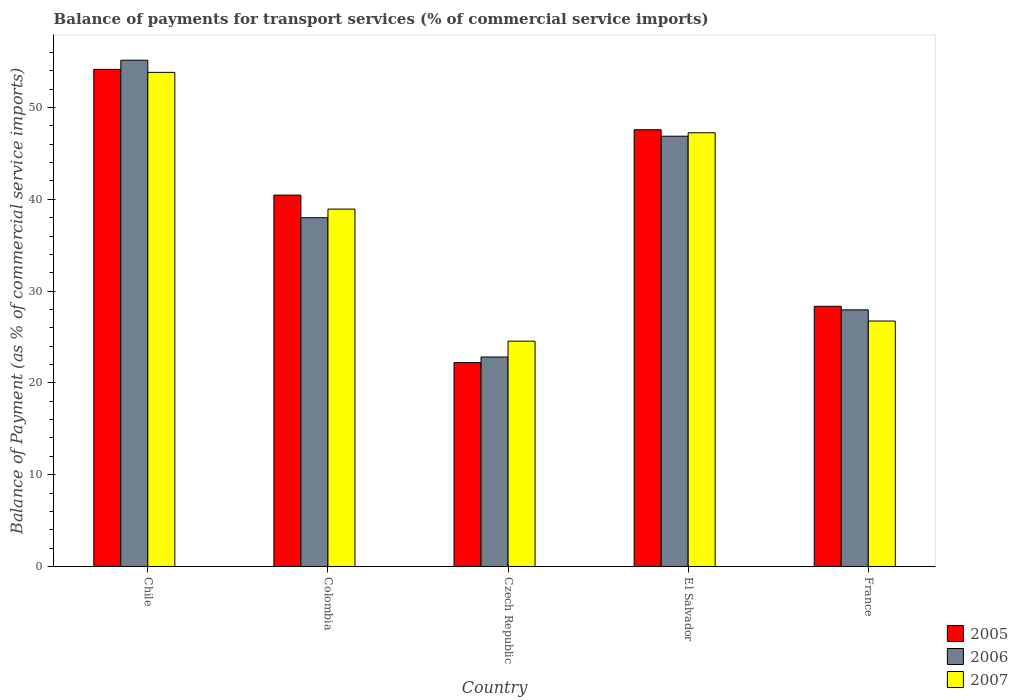How many different coloured bars are there?
Your response must be concise. 3. Are the number of bars per tick equal to the number of legend labels?
Your response must be concise. Yes. How many bars are there on the 3rd tick from the left?
Keep it short and to the point. 3. What is the label of the 1st group of bars from the left?
Ensure brevity in your answer.  Chile. What is the balance of payments for transport services in 2007 in Czech Republic?
Your response must be concise. 24.55. Across all countries, what is the maximum balance of payments for transport services in 2007?
Give a very brief answer. 53.83. Across all countries, what is the minimum balance of payments for transport services in 2007?
Give a very brief answer. 24.55. In which country was the balance of payments for transport services in 2006 minimum?
Ensure brevity in your answer.  Czech Republic. What is the total balance of payments for transport services in 2006 in the graph?
Your answer should be very brief. 190.83. What is the difference between the balance of payments for transport services in 2005 in Czech Republic and that in El Salvador?
Provide a short and direct response. -25.37. What is the difference between the balance of payments for transport services in 2007 in Colombia and the balance of payments for transport services in 2005 in Chile?
Give a very brief answer. -15.22. What is the average balance of payments for transport services in 2007 per country?
Provide a short and direct response. 38.26. What is the difference between the balance of payments for transport services of/in 2006 and balance of payments for transport services of/in 2005 in Colombia?
Your response must be concise. -2.46. In how many countries, is the balance of payments for transport services in 2005 greater than 4 %?
Give a very brief answer. 5. What is the ratio of the balance of payments for transport services in 2007 in Chile to that in France?
Your response must be concise. 2.01. Is the difference between the balance of payments for transport services in 2006 in Czech Republic and France greater than the difference between the balance of payments for transport services in 2005 in Czech Republic and France?
Offer a terse response. Yes. What is the difference between the highest and the second highest balance of payments for transport services in 2006?
Provide a short and direct response. -8.88. What is the difference between the highest and the lowest balance of payments for transport services in 2005?
Ensure brevity in your answer.  31.95. Is the sum of the balance of payments for transport services in 2007 in Colombia and Czech Republic greater than the maximum balance of payments for transport services in 2006 across all countries?
Provide a short and direct response. Yes. What does the 2nd bar from the left in Czech Republic represents?
Make the answer very short. 2006. Is it the case that in every country, the sum of the balance of payments for transport services in 2005 and balance of payments for transport services in 2006 is greater than the balance of payments for transport services in 2007?
Make the answer very short. Yes. Does the graph contain any zero values?
Your answer should be compact. No. Does the graph contain grids?
Keep it short and to the point. No. Where does the legend appear in the graph?
Offer a very short reply. Bottom right. How many legend labels are there?
Your answer should be very brief. 3. How are the legend labels stacked?
Your response must be concise. Vertical. What is the title of the graph?
Your answer should be very brief. Balance of payments for transport services (% of commercial service imports). What is the label or title of the X-axis?
Your response must be concise. Country. What is the label or title of the Y-axis?
Your answer should be very brief. Balance of Payment (as % of commercial service imports). What is the Balance of Payment (as % of commercial service imports) in 2005 in Chile?
Offer a very short reply. 54.16. What is the Balance of Payment (as % of commercial service imports) of 2006 in Chile?
Keep it short and to the point. 55.16. What is the Balance of Payment (as % of commercial service imports) of 2007 in Chile?
Make the answer very short. 53.83. What is the Balance of Payment (as % of commercial service imports) in 2005 in Colombia?
Your answer should be very brief. 40.46. What is the Balance of Payment (as % of commercial service imports) in 2006 in Colombia?
Provide a succinct answer. 38. What is the Balance of Payment (as % of commercial service imports) of 2007 in Colombia?
Provide a succinct answer. 38.94. What is the Balance of Payment (as % of commercial service imports) in 2005 in Czech Republic?
Give a very brief answer. 22.21. What is the Balance of Payment (as % of commercial service imports) in 2006 in Czech Republic?
Keep it short and to the point. 22.82. What is the Balance of Payment (as % of commercial service imports) in 2007 in Czech Republic?
Make the answer very short. 24.55. What is the Balance of Payment (as % of commercial service imports) in 2005 in El Salvador?
Your response must be concise. 47.58. What is the Balance of Payment (as % of commercial service imports) in 2006 in El Salvador?
Provide a succinct answer. 46.88. What is the Balance of Payment (as % of commercial service imports) in 2007 in El Salvador?
Provide a short and direct response. 47.25. What is the Balance of Payment (as % of commercial service imports) in 2005 in France?
Keep it short and to the point. 28.35. What is the Balance of Payment (as % of commercial service imports) of 2006 in France?
Your response must be concise. 27.96. What is the Balance of Payment (as % of commercial service imports) in 2007 in France?
Your answer should be compact. 26.74. Across all countries, what is the maximum Balance of Payment (as % of commercial service imports) in 2005?
Keep it short and to the point. 54.16. Across all countries, what is the maximum Balance of Payment (as % of commercial service imports) in 2006?
Offer a very short reply. 55.16. Across all countries, what is the maximum Balance of Payment (as % of commercial service imports) in 2007?
Provide a succinct answer. 53.83. Across all countries, what is the minimum Balance of Payment (as % of commercial service imports) in 2005?
Give a very brief answer. 22.21. Across all countries, what is the minimum Balance of Payment (as % of commercial service imports) in 2006?
Your answer should be very brief. 22.82. Across all countries, what is the minimum Balance of Payment (as % of commercial service imports) in 2007?
Provide a short and direct response. 24.55. What is the total Balance of Payment (as % of commercial service imports) in 2005 in the graph?
Keep it short and to the point. 192.76. What is the total Balance of Payment (as % of commercial service imports) in 2006 in the graph?
Your response must be concise. 190.83. What is the total Balance of Payment (as % of commercial service imports) of 2007 in the graph?
Your answer should be very brief. 191.32. What is the difference between the Balance of Payment (as % of commercial service imports) in 2005 in Chile and that in Colombia?
Offer a terse response. 13.7. What is the difference between the Balance of Payment (as % of commercial service imports) in 2006 in Chile and that in Colombia?
Keep it short and to the point. 17.16. What is the difference between the Balance of Payment (as % of commercial service imports) in 2007 in Chile and that in Colombia?
Your answer should be very brief. 14.9. What is the difference between the Balance of Payment (as % of commercial service imports) of 2005 in Chile and that in Czech Republic?
Your answer should be compact. 31.95. What is the difference between the Balance of Payment (as % of commercial service imports) in 2006 in Chile and that in Czech Republic?
Offer a terse response. 32.34. What is the difference between the Balance of Payment (as % of commercial service imports) of 2007 in Chile and that in Czech Republic?
Your response must be concise. 29.28. What is the difference between the Balance of Payment (as % of commercial service imports) in 2005 in Chile and that in El Salvador?
Make the answer very short. 6.58. What is the difference between the Balance of Payment (as % of commercial service imports) in 2006 in Chile and that in El Salvador?
Offer a very short reply. 8.28. What is the difference between the Balance of Payment (as % of commercial service imports) of 2007 in Chile and that in El Salvador?
Offer a very short reply. 6.58. What is the difference between the Balance of Payment (as % of commercial service imports) in 2005 in Chile and that in France?
Ensure brevity in your answer.  25.81. What is the difference between the Balance of Payment (as % of commercial service imports) of 2006 in Chile and that in France?
Your response must be concise. 27.2. What is the difference between the Balance of Payment (as % of commercial service imports) in 2007 in Chile and that in France?
Offer a terse response. 27.09. What is the difference between the Balance of Payment (as % of commercial service imports) of 2005 in Colombia and that in Czech Republic?
Your answer should be very brief. 18.25. What is the difference between the Balance of Payment (as % of commercial service imports) in 2006 in Colombia and that in Czech Republic?
Offer a terse response. 15.18. What is the difference between the Balance of Payment (as % of commercial service imports) in 2007 in Colombia and that in Czech Republic?
Offer a terse response. 14.39. What is the difference between the Balance of Payment (as % of commercial service imports) in 2005 in Colombia and that in El Salvador?
Offer a very short reply. -7.12. What is the difference between the Balance of Payment (as % of commercial service imports) in 2006 in Colombia and that in El Salvador?
Provide a short and direct response. -8.88. What is the difference between the Balance of Payment (as % of commercial service imports) in 2007 in Colombia and that in El Salvador?
Offer a very short reply. -8.32. What is the difference between the Balance of Payment (as % of commercial service imports) in 2005 in Colombia and that in France?
Your response must be concise. 12.11. What is the difference between the Balance of Payment (as % of commercial service imports) of 2006 in Colombia and that in France?
Offer a terse response. 10.04. What is the difference between the Balance of Payment (as % of commercial service imports) of 2007 in Colombia and that in France?
Ensure brevity in your answer.  12.2. What is the difference between the Balance of Payment (as % of commercial service imports) of 2005 in Czech Republic and that in El Salvador?
Offer a very short reply. -25.37. What is the difference between the Balance of Payment (as % of commercial service imports) in 2006 in Czech Republic and that in El Salvador?
Provide a short and direct response. -24.05. What is the difference between the Balance of Payment (as % of commercial service imports) of 2007 in Czech Republic and that in El Salvador?
Offer a very short reply. -22.7. What is the difference between the Balance of Payment (as % of commercial service imports) in 2005 in Czech Republic and that in France?
Give a very brief answer. -6.14. What is the difference between the Balance of Payment (as % of commercial service imports) of 2006 in Czech Republic and that in France?
Offer a terse response. -5.14. What is the difference between the Balance of Payment (as % of commercial service imports) of 2007 in Czech Republic and that in France?
Your answer should be very brief. -2.19. What is the difference between the Balance of Payment (as % of commercial service imports) in 2005 in El Salvador and that in France?
Keep it short and to the point. 19.23. What is the difference between the Balance of Payment (as % of commercial service imports) of 2006 in El Salvador and that in France?
Offer a very short reply. 18.92. What is the difference between the Balance of Payment (as % of commercial service imports) of 2007 in El Salvador and that in France?
Make the answer very short. 20.51. What is the difference between the Balance of Payment (as % of commercial service imports) of 2005 in Chile and the Balance of Payment (as % of commercial service imports) of 2006 in Colombia?
Ensure brevity in your answer.  16.16. What is the difference between the Balance of Payment (as % of commercial service imports) of 2005 in Chile and the Balance of Payment (as % of commercial service imports) of 2007 in Colombia?
Give a very brief answer. 15.22. What is the difference between the Balance of Payment (as % of commercial service imports) of 2006 in Chile and the Balance of Payment (as % of commercial service imports) of 2007 in Colombia?
Keep it short and to the point. 16.22. What is the difference between the Balance of Payment (as % of commercial service imports) of 2005 in Chile and the Balance of Payment (as % of commercial service imports) of 2006 in Czech Republic?
Your answer should be very brief. 31.34. What is the difference between the Balance of Payment (as % of commercial service imports) of 2005 in Chile and the Balance of Payment (as % of commercial service imports) of 2007 in Czech Republic?
Your answer should be compact. 29.61. What is the difference between the Balance of Payment (as % of commercial service imports) in 2006 in Chile and the Balance of Payment (as % of commercial service imports) in 2007 in Czech Republic?
Ensure brevity in your answer.  30.61. What is the difference between the Balance of Payment (as % of commercial service imports) in 2005 in Chile and the Balance of Payment (as % of commercial service imports) in 2006 in El Salvador?
Offer a very short reply. 7.28. What is the difference between the Balance of Payment (as % of commercial service imports) of 2005 in Chile and the Balance of Payment (as % of commercial service imports) of 2007 in El Salvador?
Keep it short and to the point. 6.91. What is the difference between the Balance of Payment (as % of commercial service imports) of 2006 in Chile and the Balance of Payment (as % of commercial service imports) of 2007 in El Salvador?
Make the answer very short. 7.91. What is the difference between the Balance of Payment (as % of commercial service imports) of 2005 in Chile and the Balance of Payment (as % of commercial service imports) of 2006 in France?
Give a very brief answer. 26.2. What is the difference between the Balance of Payment (as % of commercial service imports) of 2005 in Chile and the Balance of Payment (as % of commercial service imports) of 2007 in France?
Your answer should be very brief. 27.42. What is the difference between the Balance of Payment (as % of commercial service imports) in 2006 in Chile and the Balance of Payment (as % of commercial service imports) in 2007 in France?
Your answer should be very brief. 28.42. What is the difference between the Balance of Payment (as % of commercial service imports) of 2005 in Colombia and the Balance of Payment (as % of commercial service imports) of 2006 in Czech Republic?
Your answer should be very brief. 17.64. What is the difference between the Balance of Payment (as % of commercial service imports) in 2005 in Colombia and the Balance of Payment (as % of commercial service imports) in 2007 in Czech Republic?
Ensure brevity in your answer.  15.91. What is the difference between the Balance of Payment (as % of commercial service imports) in 2006 in Colombia and the Balance of Payment (as % of commercial service imports) in 2007 in Czech Republic?
Keep it short and to the point. 13.45. What is the difference between the Balance of Payment (as % of commercial service imports) in 2005 in Colombia and the Balance of Payment (as % of commercial service imports) in 2006 in El Salvador?
Offer a terse response. -6.42. What is the difference between the Balance of Payment (as % of commercial service imports) of 2005 in Colombia and the Balance of Payment (as % of commercial service imports) of 2007 in El Salvador?
Offer a very short reply. -6.79. What is the difference between the Balance of Payment (as % of commercial service imports) in 2006 in Colombia and the Balance of Payment (as % of commercial service imports) in 2007 in El Salvador?
Provide a short and direct response. -9.25. What is the difference between the Balance of Payment (as % of commercial service imports) in 2005 in Colombia and the Balance of Payment (as % of commercial service imports) in 2006 in France?
Keep it short and to the point. 12.5. What is the difference between the Balance of Payment (as % of commercial service imports) of 2005 in Colombia and the Balance of Payment (as % of commercial service imports) of 2007 in France?
Keep it short and to the point. 13.72. What is the difference between the Balance of Payment (as % of commercial service imports) of 2006 in Colombia and the Balance of Payment (as % of commercial service imports) of 2007 in France?
Provide a succinct answer. 11.26. What is the difference between the Balance of Payment (as % of commercial service imports) of 2005 in Czech Republic and the Balance of Payment (as % of commercial service imports) of 2006 in El Salvador?
Your answer should be compact. -24.67. What is the difference between the Balance of Payment (as % of commercial service imports) in 2005 in Czech Republic and the Balance of Payment (as % of commercial service imports) in 2007 in El Salvador?
Your answer should be very brief. -25.04. What is the difference between the Balance of Payment (as % of commercial service imports) of 2006 in Czech Republic and the Balance of Payment (as % of commercial service imports) of 2007 in El Salvador?
Your answer should be compact. -24.43. What is the difference between the Balance of Payment (as % of commercial service imports) of 2005 in Czech Republic and the Balance of Payment (as % of commercial service imports) of 2006 in France?
Keep it short and to the point. -5.75. What is the difference between the Balance of Payment (as % of commercial service imports) of 2005 in Czech Republic and the Balance of Payment (as % of commercial service imports) of 2007 in France?
Provide a short and direct response. -4.53. What is the difference between the Balance of Payment (as % of commercial service imports) in 2006 in Czech Republic and the Balance of Payment (as % of commercial service imports) in 2007 in France?
Keep it short and to the point. -3.92. What is the difference between the Balance of Payment (as % of commercial service imports) in 2005 in El Salvador and the Balance of Payment (as % of commercial service imports) in 2006 in France?
Provide a short and direct response. 19.62. What is the difference between the Balance of Payment (as % of commercial service imports) of 2005 in El Salvador and the Balance of Payment (as % of commercial service imports) of 2007 in France?
Your answer should be compact. 20.84. What is the difference between the Balance of Payment (as % of commercial service imports) of 2006 in El Salvador and the Balance of Payment (as % of commercial service imports) of 2007 in France?
Your answer should be compact. 20.14. What is the average Balance of Payment (as % of commercial service imports) in 2005 per country?
Provide a succinct answer. 38.55. What is the average Balance of Payment (as % of commercial service imports) of 2006 per country?
Ensure brevity in your answer.  38.17. What is the average Balance of Payment (as % of commercial service imports) of 2007 per country?
Your answer should be very brief. 38.26. What is the difference between the Balance of Payment (as % of commercial service imports) in 2005 and Balance of Payment (as % of commercial service imports) in 2006 in Chile?
Keep it short and to the point. -1. What is the difference between the Balance of Payment (as % of commercial service imports) of 2005 and Balance of Payment (as % of commercial service imports) of 2007 in Chile?
Keep it short and to the point. 0.33. What is the difference between the Balance of Payment (as % of commercial service imports) in 2006 and Balance of Payment (as % of commercial service imports) in 2007 in Chile?
Give a very brief answer. 1.33. What is the difference between the Balance of Payment (as % of commercial service imports) in 2005 and Balance of Payment (as % of commercial service imports) in 2006 in Colombia?
Your answer should be compact. 2.46. What is the difference between the Balance of Payment (as % of commercial service imports) of 2005 and Balance of Payment (as % of commercial service imports) of 2007 in Colombia?
Make the answer very short. 1.52. What is the difference between the Balance of Payment (as % of commercial service imports) in 2006 and Balance of Payment (as % of commercial service imports) in 2007 in Colombia?
Keep it short and to the point. -0.94. What is the difference between the Balance of Payment (as % of commercial service imports) of 2005 and Balance of Payment (as % of commercial service imports) of 2006 in Czech Republic?
Your answer should be compact. -0.61. What is the difference between the Balance of Payment (as % of commercial service imports) in 2005 and Balance of Payment (as % of commercial service imports) in 2007 in Czech Republic?
Your response must be concise. -2.34. What is the difference between the Balance of Payment (as % of commercial service imports) of 2006 and Balance of Payment (as % of commercial service imports) of 2007 in Czech Republic?
Provide a succinct answer. -1.72. What is the difference between the Balance of Payment (as % of commercial service imports) of 2005 and Balance of Payment (as % of commercial service imports) of 2006 in El Salvador?
Provide a short and direct response. 0.7. What is the difference between the Balance of Payment (as % of commercial service imports) in 2005 and Balance of Payment (as % of commercial service imports) in 2007 in El Salvador?
Make the answer very short. 0.33. What is the difference between the Balance of Payment (as % of commercial service imports) of 2006 and Balance of Payment (as % of commercial service imports) of 2007 in El Salvador?
Make the answer very short. -0.38. What is the difference between the Balance of Payment (as % of commercial service imports) of 2005 and Balance of Payment (as % of commercial service imports) of 2006 in France?
Provide a succinct answer. 0.39. What is the difference between the Balance of Payment (as % of commercial service imports) in 2005 and Balance of Payment (as % of commercial service imports) in 2007 in France?
Offer a very short reply. 1.61. What is the difference between the Balance of Payment (as % of commercial service imports) in 2006 and Balance of Payment (as % of commercial service imports) in 2007 in France?
Your answer should be compact. 1.22. What is the ratio of the Balance of Payment (as % of commercial service imports) of 2005 in Chile to that in Colombia?
Keep it short and to the point. 1.34. What is the ratio of the Balance of Payment (as % of commercial service imports) in 2006 in Chile to that in Colombia?
Give a very brief answer. 1.45. What is the ratio of the Balance of Payment (as % of commercial service imports) of 2007 in Chile to that in Colombia?
Provide a succinct answer. 1.38. What is the ratio of the Balance of Payment (as % of commercial service imports) of 2005 in Chile to that in Czech Republic?
Ensure brevity in your answer.  2.44. What is the ratio of the Balance of Payment (as % of commercial service imports) of 2006 in Chile to that in Czech Republic?
Keep it short and to the point. 2.42. What is the ratio of the Balance of Payment (as % of commercial service imports) of 2007 in Chile to that in Czech Republic?
Your answer should be very brief. 2.19. What is the ratio of the Balance of Payment (as % of commercial service imports) of 2005 in Chile to that in El Salvador?
Your answer should be very brief. 1.14. What is the ratio of the Balance of Payment (as % of commercial service imports) of 2006 in Chile to that in El Salvador?
Offer a terse response. 1.18. What is the ratio of the Balance of Payment (as % of commercial service imports) in 2007 in Chile to that in El Salvador?
Your answer should be compact. 1.14. What is the ratio of the Balance of Payment (as % of commercial service imports) of 2005 in Chile to that in France?
Your response must be concise. 1.91. What is the ratio of the Balance of Payment (as % of commercial service imports) in 2006 in Chile to that in France?
Give a very brief answer. 1.97. What is the ratio of the Balance of Payment (as % of commercial service imports) in 2007 in Chile to that in France?
Provide a short and direct response. 2.01. What is the ratio of the Balance of Payment (as % of commercial service imports) of 2005 in Colombia to that in Czech Republic?
Make the answer very short. 1.82. What is the ratio of the Balance of Payment (as % of commercial service imports) of 2006 in Colombia to that in Czech Republic?
Make the answer very short. 1.66. What is the ratio of the Balance of Payment (as % of commercial service imports) of 2007 in Colombia to that in Czech Republic?
Keep it short and to the point. 1.59. What is the ratio of the Balance of Payment (as % of commercial service imports) of 2005 in Colombia to that in El Salvador?
Provide a short and direct response. 0.85. What is the ratio of the Balance of Payment (as % of commercial service imports) in 2006 in Colombia to that in El Salvador?
Offer a very short reply. 0.81. What is the ratio of the Balance of Payment (as % of commercial service imports) of 2007 in Colombia to that in El Salvador?
Your answer should be compact. 0.82. What is the ratio of the Balance of Payment (as % of commercial service imports) in 2005 in Colombia to that in France?
Your response must be concise. 1.43. What is the ratio of the Balance of Payment (as % of commercial service imports) of 2006 in Colombia to that in France?
Give a very brief answer. 1.36. What is the ratio of the Balance of Payment (as % of commercial service imports) in 2007 in Colombia to that in France?
Your answer should be very brief. 1.46. What is the ratio of the Balance of Payment (as % of commercial service imports) in 2005 in Czech Republic to that in El Salvador?
Your answer should be very brief. 0.47. What is the ratio of the Balance of Payment (as % of commercial service imports) in 2006 in Czech Republic to that in El Salvador?
Give a very brief answer. 0.49. What is the ratio of the Balance of Payment (as % of commercial service imports) of 2007 in Czech Republic to that in El Salvador?
Ensure brevity in your answer.  0.52. What is the ratio of the Balance of Payment (as % of commercial service imports) of 2005 in Czech Republic to that in France?
Your answer should be very brief. 0.78. What is the ratio of the Balance of Payment (as % of commercial service imports) of 2006 in Czech Republic to that in France?
Offer a very short reply. 0.82. What is the ratio of the Balance of Payment (as % of commercial service imports) of 2007 in Czech Republic to that in France?
Offer a very short reply. 0.92. What is the ratio of the Balance of Payment (as % of commercial service imports) in 2005 in El Salvador to that in France?
Your response must be concise. 1.68. What is the ratio of the Balance of Payment (as % of commercial service imports) in 2006 in El Salvador to that in France?
Give a very brief answer. 1.68. What is the ratio of the Balance of Payment (as % of commercial service imports) in 2007 in El Salvador to that in France?
Make the answer very short. 1.77. What is the difference between the highest and the second highest Balance of Payment (as % of commercial service imports) of 2005?
Provide a succinct answer. 6.58. What is the difference between the highest and the second highest Balance of Payment (as % of commercial service imports) in 2006?
Offer a very short reply. 8.28. What is the difference between the highest and the second highest Balance of Payment (as % of commercial service imports) in 2007?
Provide a short and direct response. 6.58. What is the difference between the highest and the lowest Balance of Payment (as % of commercial service imports) in 2005?
Ensure brevity in your answer.  31.95. What is the difference between the highest and the lowest Balance of Payment (as % of commercial service imports) of 2006?
Keep it short and to the point. 32.34. What is the difference between the highest and the lowest Balance of Payment (as % of commercial service imports) in 2007?
Offer a terse response. 29.28. 